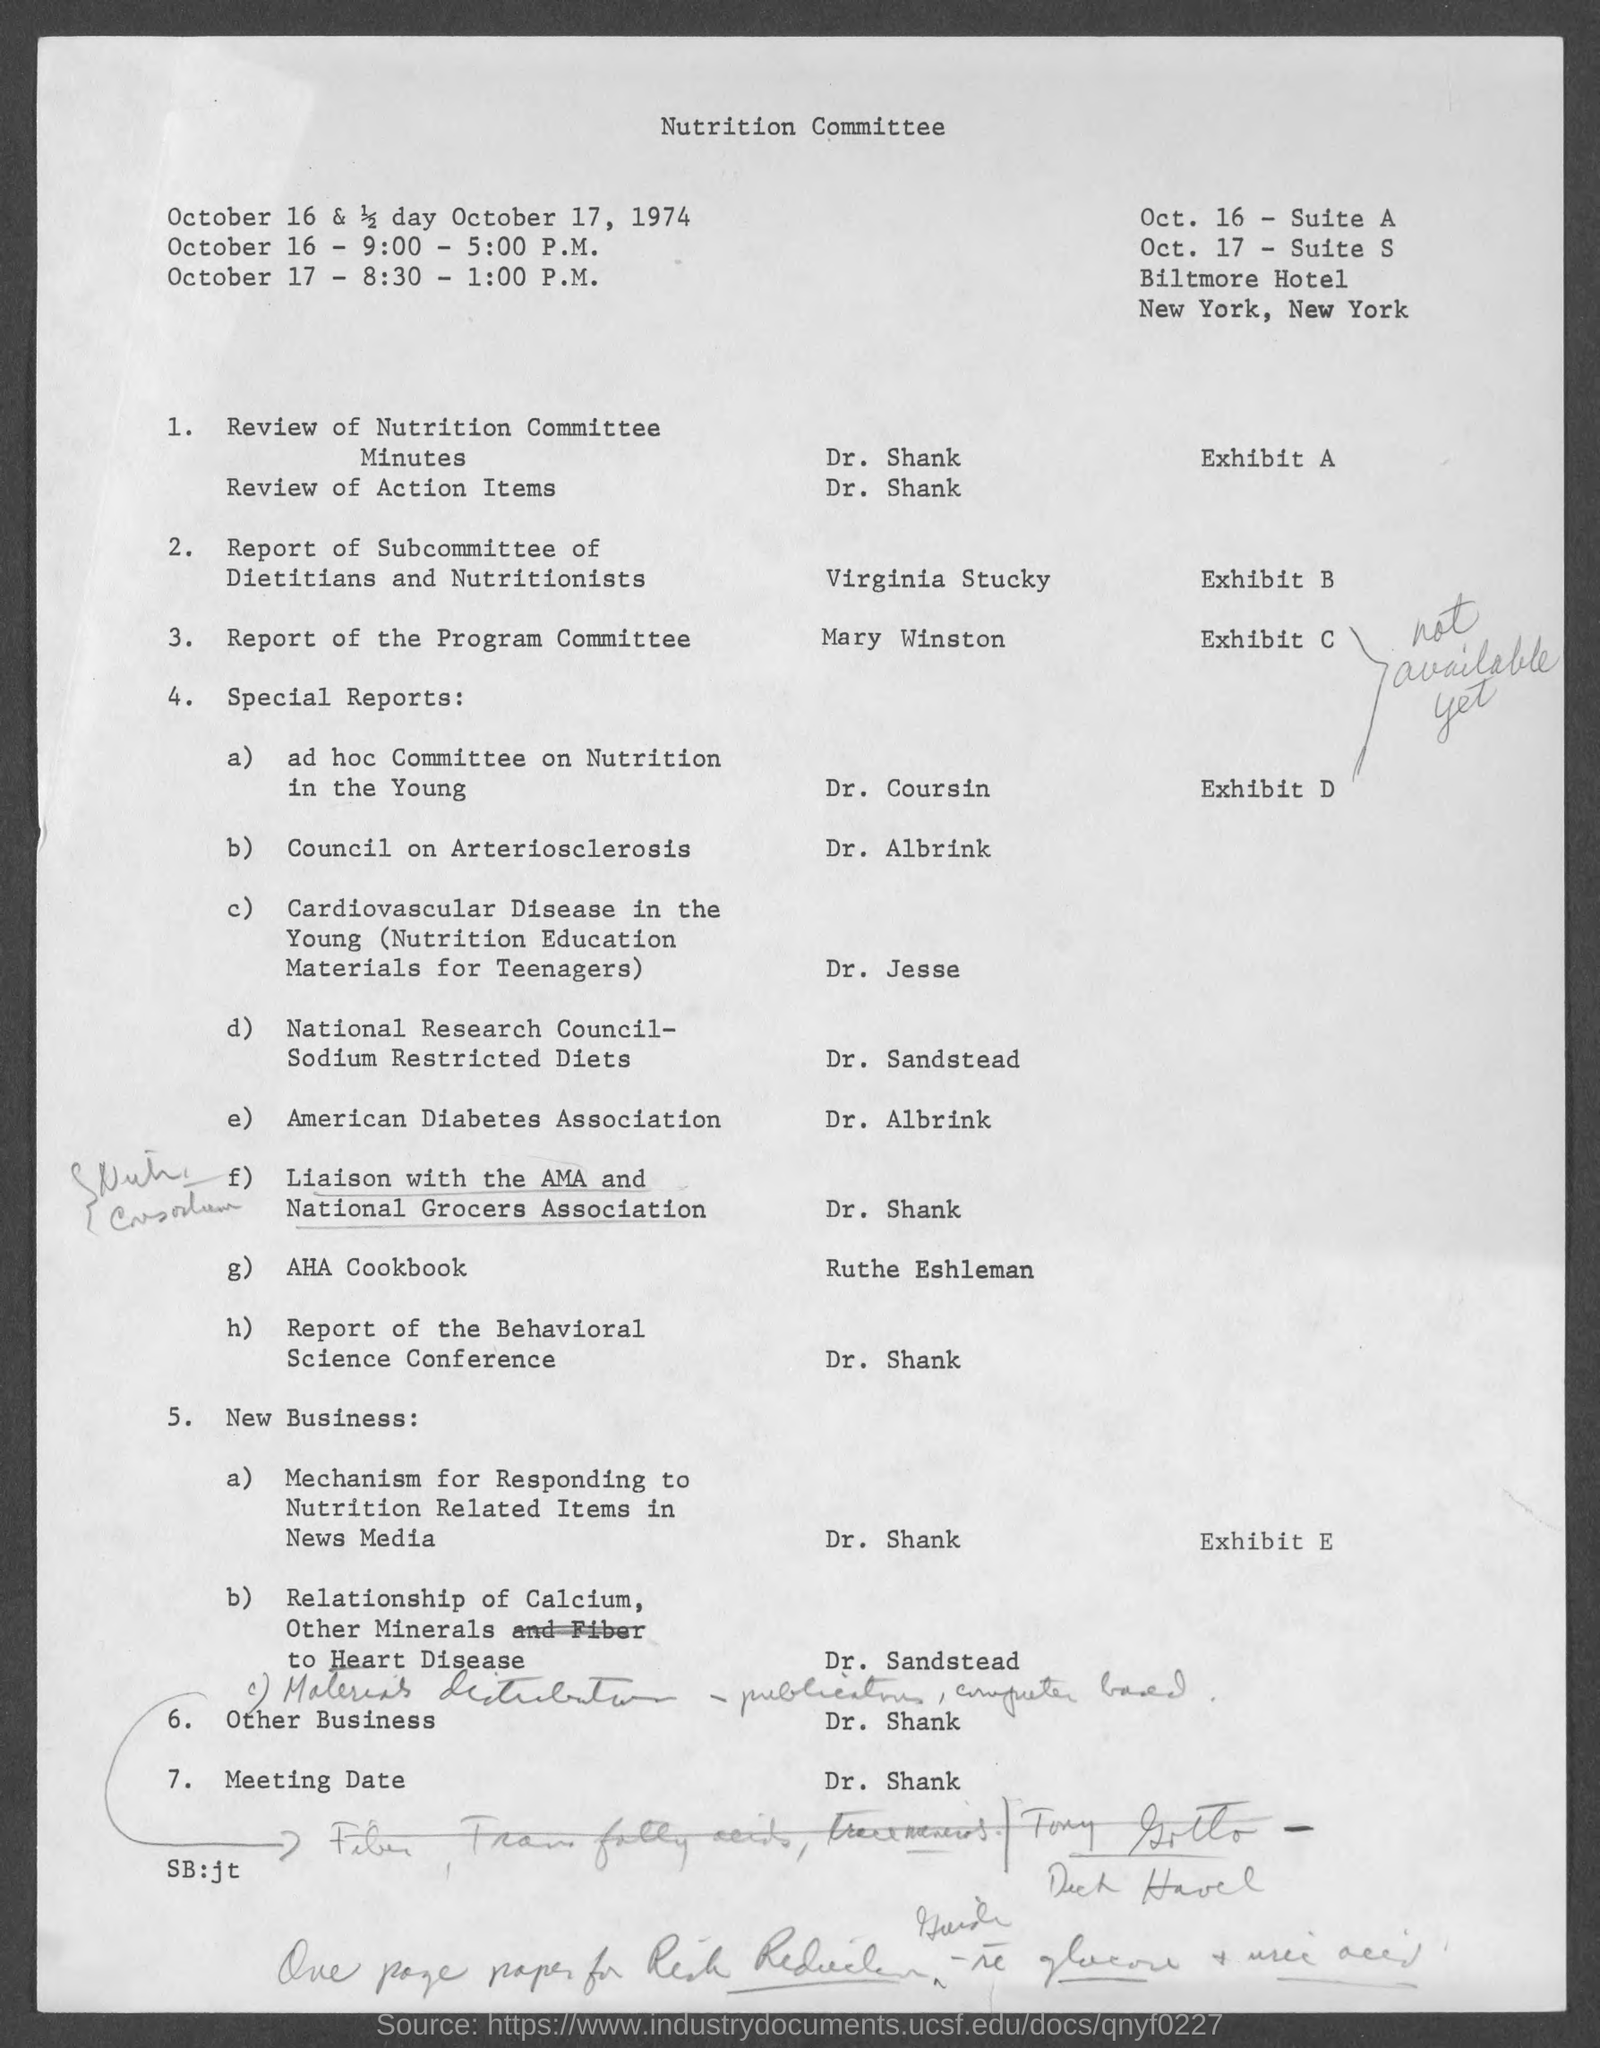Who is presenting the Review of Nutrition Committee Minutes?
Keep it short and to the point. Dr. Shank. Who is presenting the Report of the Program Committee?
Provide a short and direct response. Mary Winston. Who is presenting the special reports on American Diabetes Association?
Your answer should be compact. Dr. Albrink. Who is presenting the report of the Behavioral Science Conference?
Provide a short and direct response. Dr. Shank. 